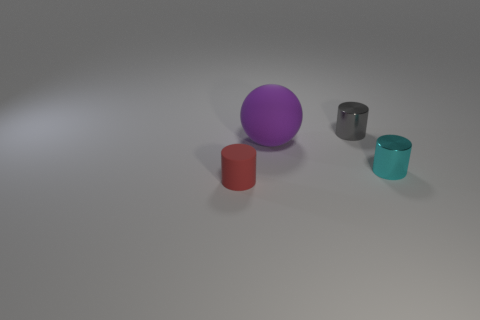Are any green metal cylinders visible?
Your answer should be very brief. No. There is a red object that is the same shape as the small gray object; what material is it?
Ensure brevity in your answer.  Rubber. What shape is the object that is in front of the thing that is right of the tiny metallic cylinder that is behind the big purple thing?
Your answer should be very brief. Cylinder. What number of gray objects have the same shape as the cyan thing?
Your answer should be compact. 1. There is a red cylinder that is the same size as the cyan thing; what material is it?
Provide a short and direct response. Rubber. Are there any red rubber objects that have the same size as the gray metal cylinder?
Offer a very short reply. Yes. Is the number of objects that are in front of the matte sphere less than the number of small cylinders?
Ensure brevity in your answer.  Yes. Is the number of rubber balls behind the rubber ball less than the number of purple matte balls that are on the right side of the tiny gray cylinder?
Keep it short and to the point. No. What number of cylinders are small red things or small things?
Keep it short and to the point. 3. Does the small cylinder to the left of the small gray object have the same material as the large sphere in front of the tiny gray metal cylinder?
Your answer should be compact. Yes. 